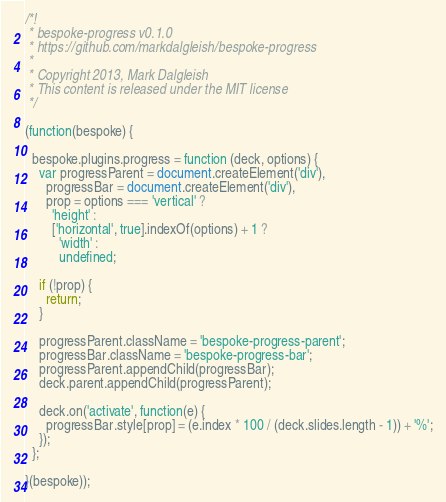Convert code to text. <code><loc_0><loc_0><loc_500><loc_500><_JavaScript_>/*!
 * bespoke-progress v0.1.0
 * https://github.com/markdalgleish/bespoke-progress
 *
 * Copyright 2013, Mark Dalgleish
 * This content is released under the MIT license
 */

(function(bespoke) {

  bespoke.plugins.progress = function (deck, options) {
    var progressParent = document.createElement('div'),
      progressBar = document.createElement('div'),
      prop = options === 'vertical' ?
        'height' :
        ['horizontal', true].indexOf(options) + 1 ?
          'width' :
          undefined;

    if (!prop) {
      return;
    }

    progressParent.className = 'bespoke-progress-parent';
    progressBar.className = 'bespoke-progress-bar';
    progressParent.appendChild(progressBar);
    deck.parent.appendChild(progressParent);

    deck.on('activate', function(e) {
      progressBar.style[prop] = (e.index * 100 / (deck.slides.length - 1)) + '%';
    });
  };

}(bespoke));
</code> 